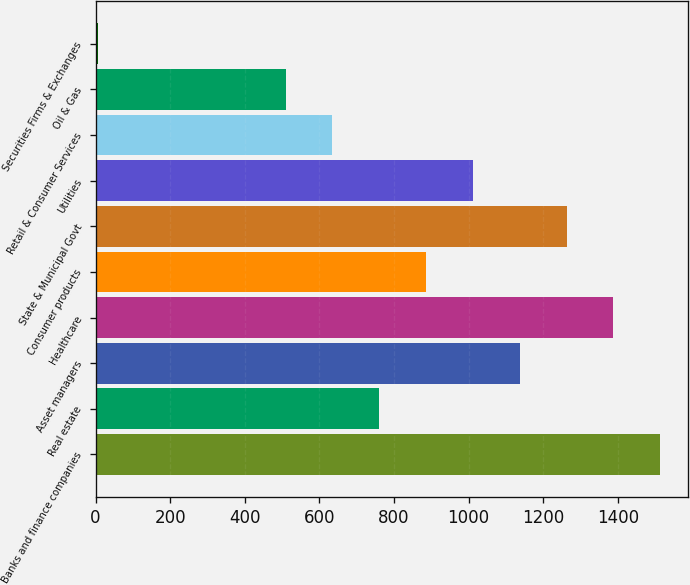Convert chart to OTSL. <chart><loc_0><loc_0><loc_500><loc_500><bar_chart><fcel>Banks and finance companies<fcel>Real estate<fcel>Asset managers<fcel>Healthcare<fcel>Consumer products<fcel>State & Municipal Govt<fcel>Utilities<fcel>Retail & Consumer Services<fcel>Oil & Gas<fcel>Securities Firms & Exchanges<nl><fcel>1513.7<fcel>760.4<fcel>1137.05<fcel>1388.15<fcel>885.95<fcel>1262.6<fcel>1011.5<fcel>634.85<fcel>509.3<fcel>7.1<nl></chart> 